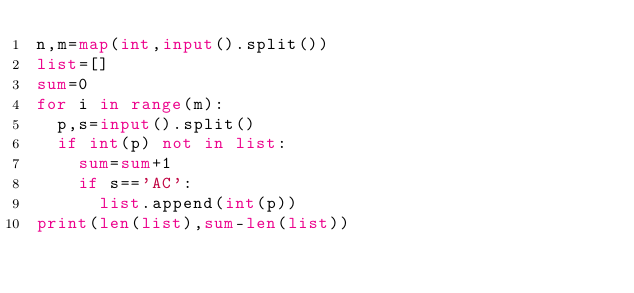Convert code to text. <code><loc_0><loc_0><loc_500><loc_500><_Python_>n,m=map(int,input().split())
list=[]
sum=0
for i in range(m):
  p,s=input().split()
  if int(p) not in list:
    sum=sum+1
    if s=='AC':
      list.append(int(p))
print(len(list),sum-len(list))</code> 